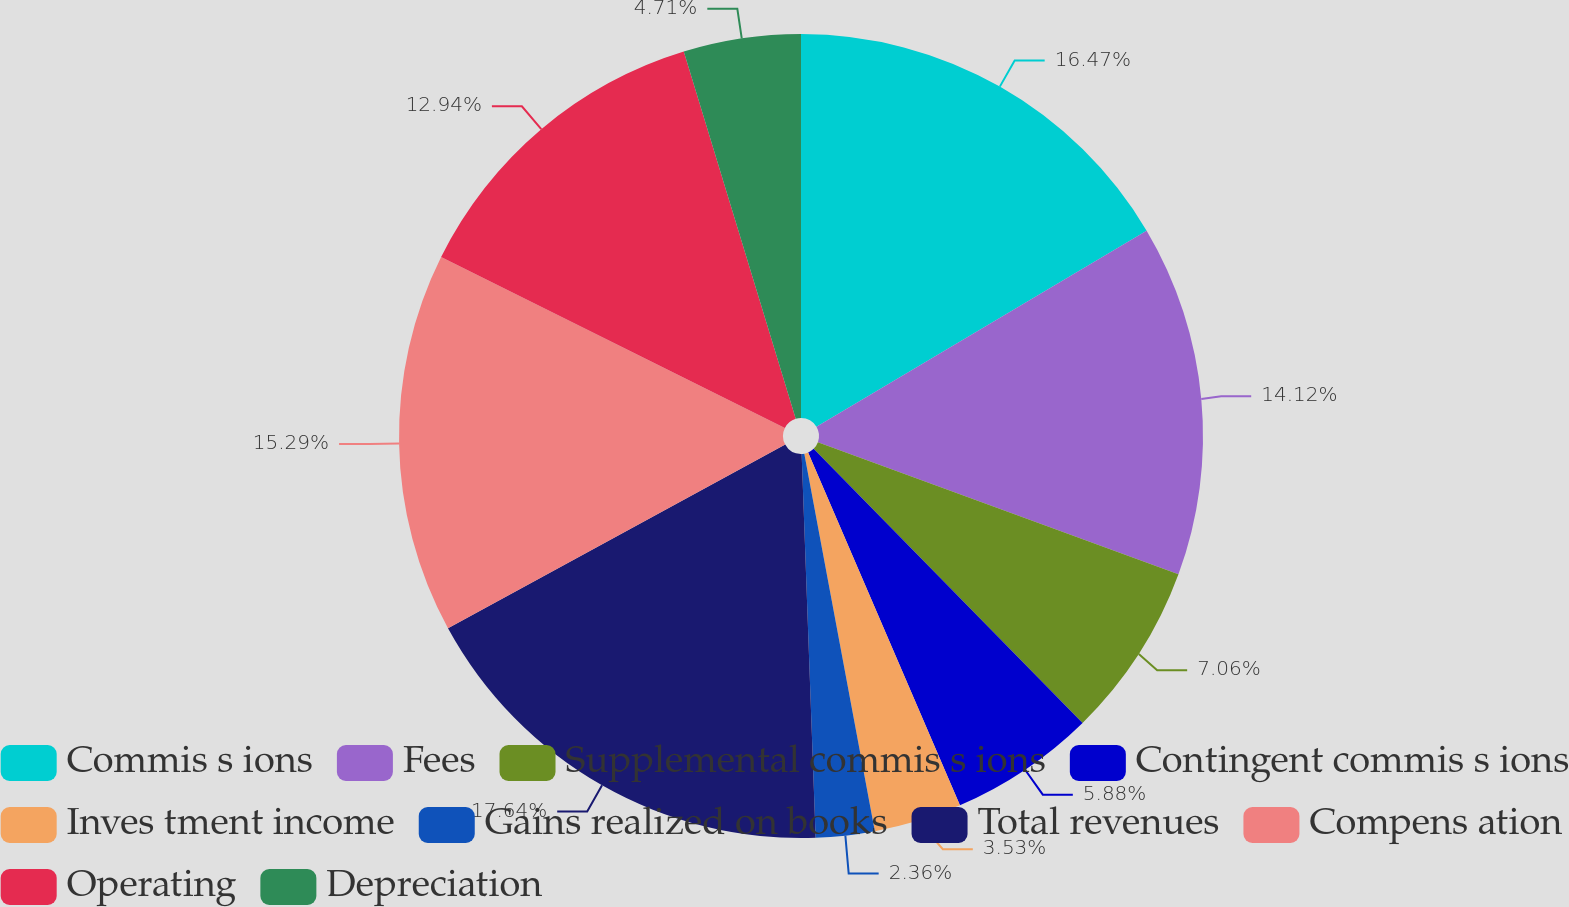<chart> <loc_0><loc_0><loc_500><loc_500><pie_chart><fcel>Commis s ions<fcel>Fees<fcel>Supplemental commis s ions<fcel>Contingent commis s ions<fcel>Inves tment income<fcel>Gains realized on books<fcel>Total revenues<fcel>Compens ation<fcel>Operating<fcel>Depreciation<nl><fcel>16.47%<fcel>14.12%<fcel>7.06%<fcel>5.88%<fcel>3.53%<fcel>2.36%<fcel>17.64%<fcel>15.29%<fcel>12.94%<fcel>4.71%<nl></chart> 